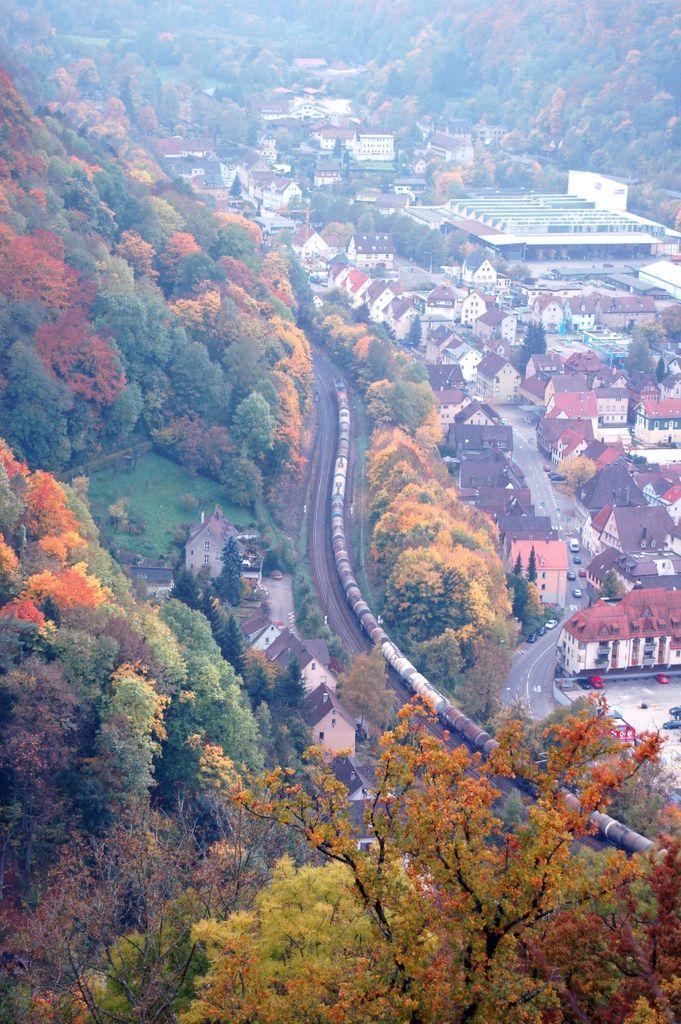How would you summarize this image in a sentence or two? In the image we can see there are lot of trees and there is a goods train. There are lot of buildings. 